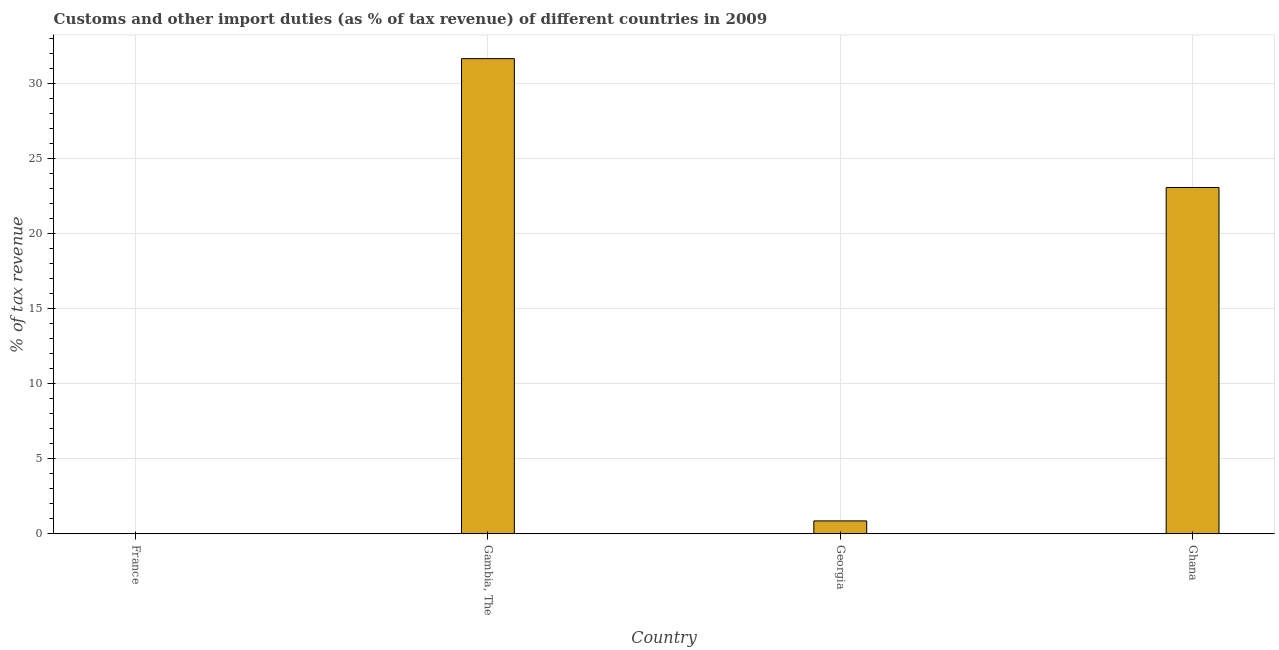What is the title of the graph?
Give a very brief answer. Customs and other import duties (as % of tax revenue) of different countries in 2009. What is the label or title of the X-axis?
Make the answer very short. Country. What is the label or title of the Y-axis?
Provide a succinct answer. % of tax revenue. What is the customs and other import duties in Ghana?
Provide a succinct answer. 23.06. Across all countries, what is the maximum customs and other import duties?
Offer a terse response. 31.64. Across all countries, what is the minimum customs and other import duties?
Ensure brevity in your answer.  0. In which country was the customs and other import duties maximum?
Offer a very short reply. Gambia, The. What is the sum of the customs and other import duties?
Offer a terse response. 55.56. What is the difference between the customs and other import duties in Gambia, The and Ghana?
Offer a terse response. 8.58. What is the average customs and other import duties per country?
Your response must be concise. 13.89. What is the median customs and other import duties?
Your answer should be very brief. 11.96. What is the ratio of the customs and other import duties in Georgia to that in Ghana?
Offer a terse response. 0.04. Is the customs and other import duties in Georgia less than that in Ghana?
Offer a terse response. Yes. Is the difference between the customs and other import duties in Gambia, The and Ghana greater than the difference between any two countries?
Your answer should be compact. No. What is the difference between the highest and the second highest customs and other import duties?
Your answer should be compact. 8.58. Is the sum of the customs and other import duties in Gambia, The and Ghana greater than the maximum customs and other import duties across all countries?
Offer a very short reply. Yes. What is the difference between the highest and the lowest customs and other import duties?
Offer a terse response. 31.64. In how many countries, is the customs and other import duties greater than the average customs and other import duties taken over all countries?
Offer a very short reply. 2. Are all the bars in the graph horizontal?
Your response must be concise. No. What is the difference between two consecutive major ticks on the Y-axis?
Offer a terse response. 5. What is the % of tax revenue in Gambia, The?
Offer a very short reply. 31.64. What is the % of tax revenue in Georgia?
Your response must be concise. 0.86. What is the % of tax revenue of Ghana?
Your response must be concise. 23.06. What is the difference between the % of tax revenue in Gambia, The and Georgia?
Your answer should be very brief. 30.77. What is the difference between the % of tax revenue in Gambia, The and Ghana?
Provide a succinct answer. 8.58. What is the difference between the % of tax revenue in Georgia and Ghana?
Offer a terse response. -22.2. What is the ratio of the % of tax revenue in Gambia, The to that in Georgia?
Your response must be concise. 36.67. What is the ratio of the % of tax revenue in Gambia, The to that in Ghana?
Provide a succinct answer. 1.37. What is the ratio of the % of tax revenue in Georgia to that in Ghana?
Keep it short and to the point. 0.04. 